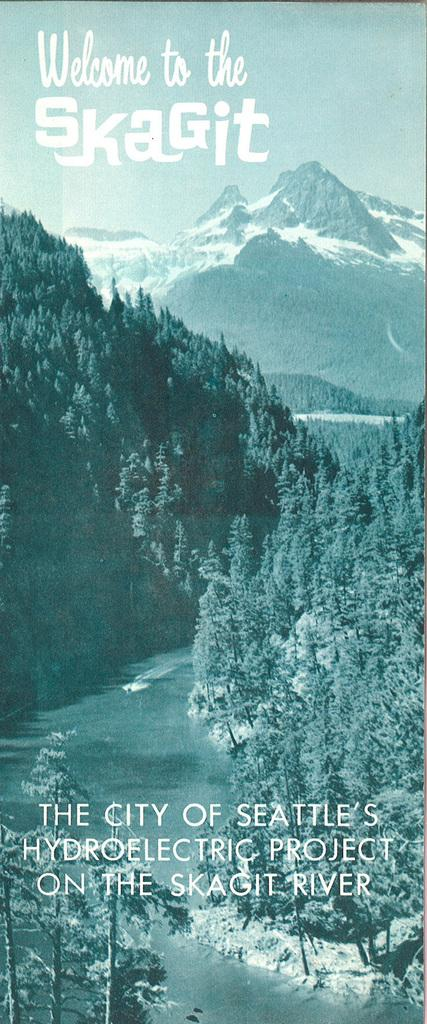What type of natural environment is depicted in the image? The image features trees, water, and mountains, which are all elements of a natural environment. Can you describe the water in the image? There is water visible in the image, but its specific characteristics are not mentioned in the facts. What type of text or writing is present in the image? The facts mention that there is text or writing present in the image, but its content or purpose is not specified. How many minutes does it take for the trees to laugh in the image? There is no indication in the image that the trees are laughing, nor is there any mention of time in the facts provided. 